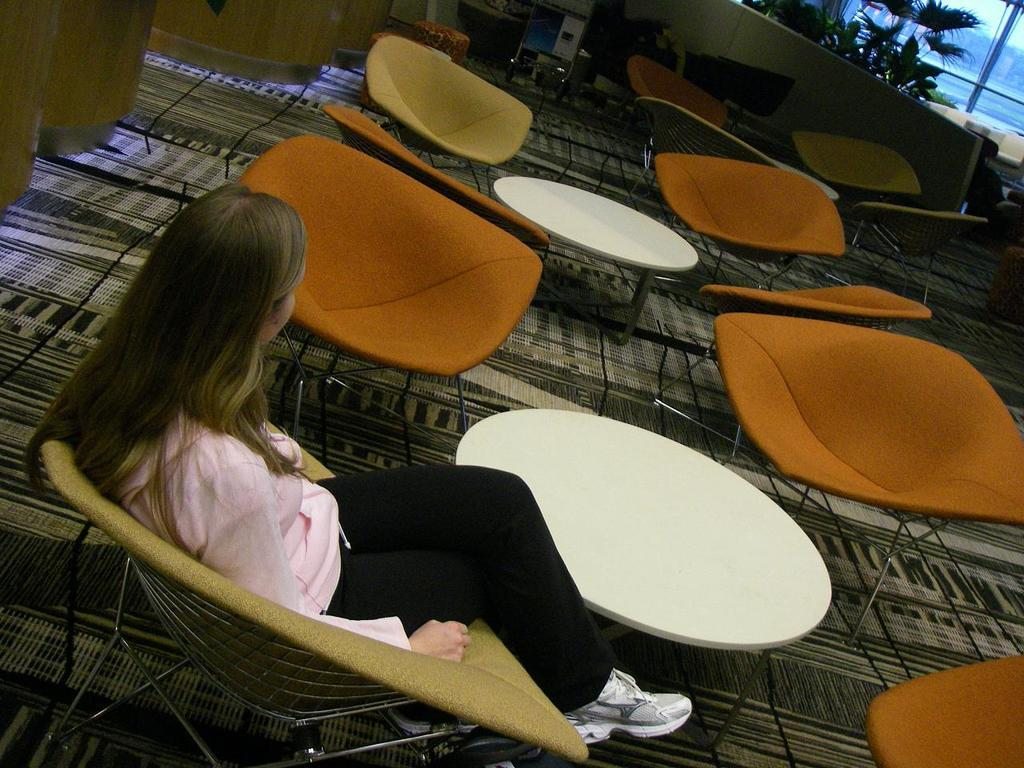What type of furniture is present in the image? There is a table and a chair in the image. What is the woman doing in the image? The woman is sitting on the chair. How many rabbits can be seen playing with the frog in the image? There are no rabbits or frogs present in the image. 